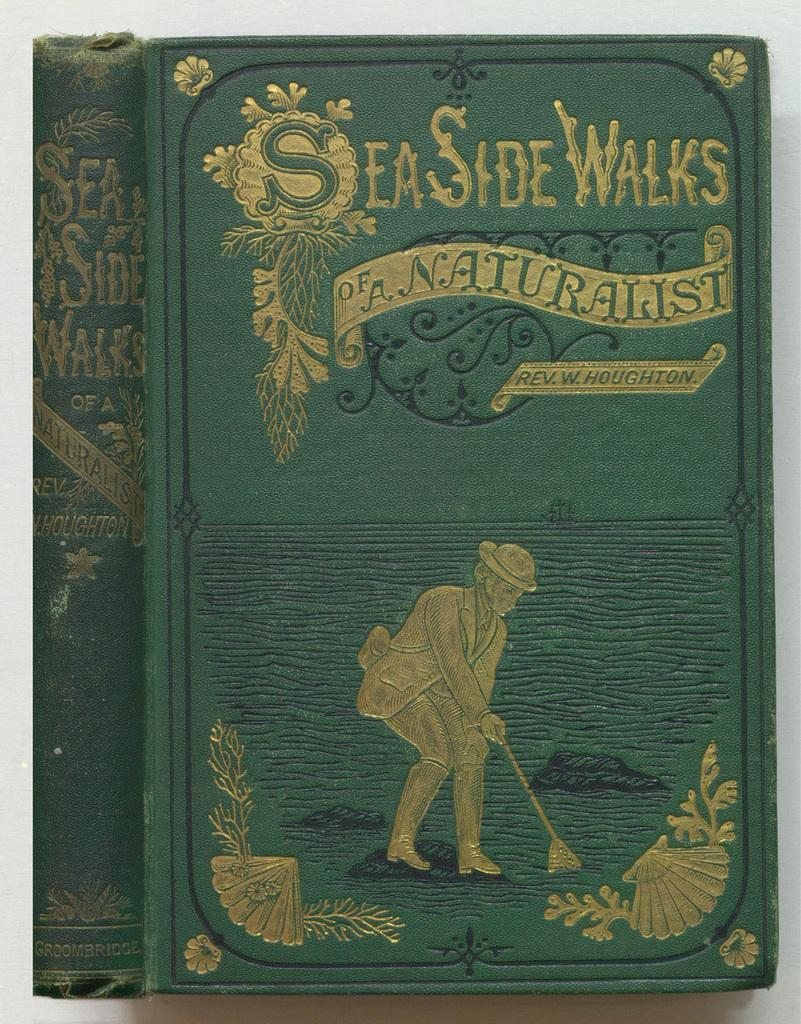<image>
Write a terse but informative summary of the picture. Green book titled Seaside Walks on top of a table. 